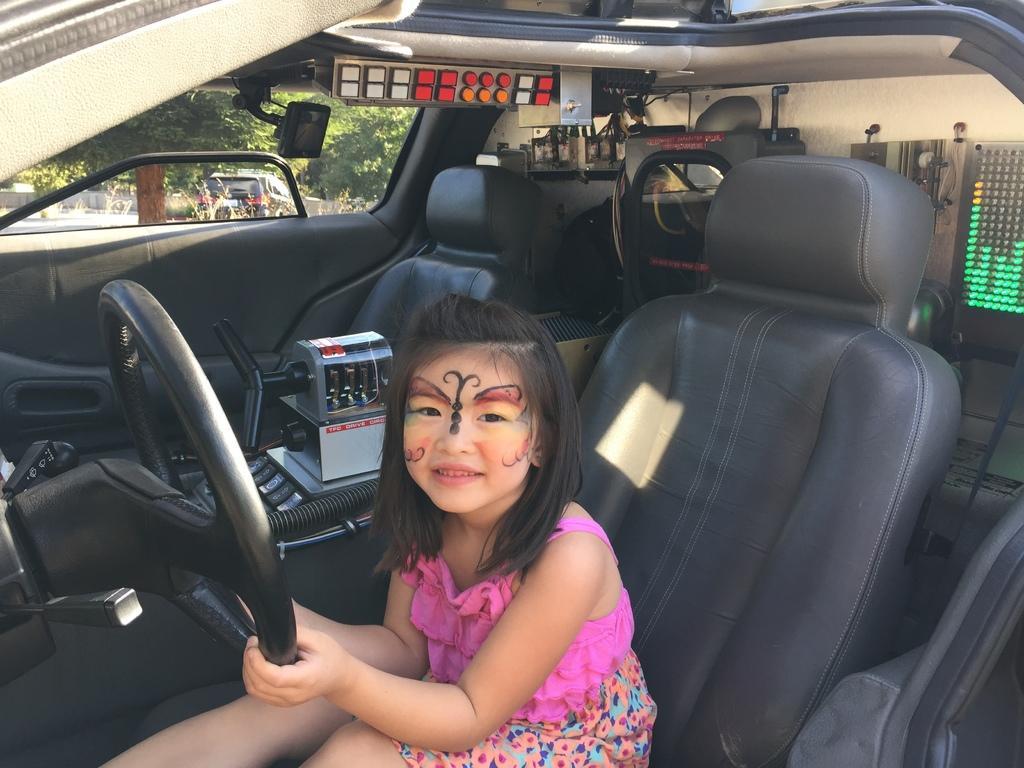Could you give a brief overview of what you see in this image? This girl is sitting inside his car and holding a steering. We can able to see trees and vehicles from this window. 